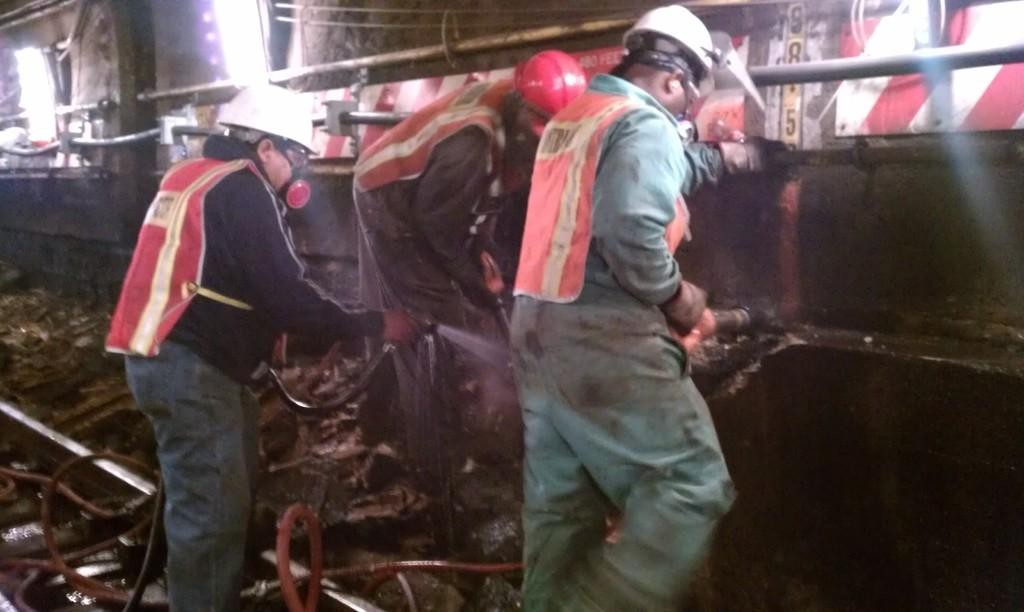How many people are in the image? There are three persons in the image. What are the persons holding in their hands? The persons are holding pipes in their hands. What can be seen beneath the persons in the image? There is ground visible in the image. What is visible in the background of the image? There is a wall, rods, and lights in the background of the image. What color is the goldfish swimming in the image? There is no goldfish present in the image. Is the queen in the image wearing a crown? There is no queen or any indication of royalty in the image. 